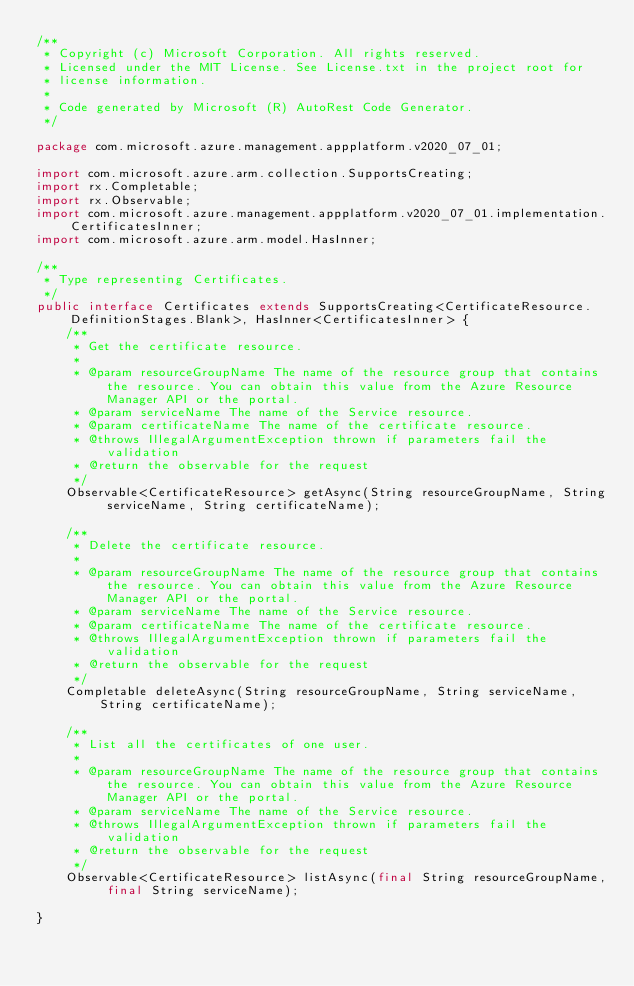<code> <loc_0><loc_0><loc_500><loc_500><_Java_>/**
 * Copyright (c) Microsoft Corporation. All rights reserved.
 * Licensed under the MIT License. See License.txt in the project root for
 * license information.
 *
 * Code generated by Microsoft (R) AutoRest Code Generator.
 */

package com.microsoft.azure.management.appplatform.v2020_07_01;

import com.microsoft.azure.arm.collection.SupportsCreating;
import rx.Completable;
import rx.Observable;
import com.microsoft.azure.management.appplatform.v2020_07_01.implementation.CertificatesInner;
import com.microsoft.azure.arm.model.HasInner;

/**
 * Type representing Certificates.
 */
public interface Certificates extends SupportsCreating<CertificateResource.DefinitionStages.Blank>, HasInner<CertificatesInner> {
    /**
     * Get the certificate resource.
     *
     * @param resourceGroupName The name of the resource group that contains the resource. You can obtain this value from the Azure Resource Manager API or the portal.
     * @param serviceName The name of the Service resource.
     * @param certificateName The name of the certificate resource.
     * @throws IllegalArgumentException thrown if parameters fail the validation
     * @return the observable for the request
     */
    Observable<CertificateResource> getAsync(String resourceGroupName, String serviceName, String certificateName);

    /**
     * Delete the certificate resource.
     *
     * @param resourceGroupName The name of the resource group that contains the resource. You can obtain this value from the Azure Resource Manager API or the portal.
     * @param serviceName The name of the Service resource.
     * @param certificateName The name of the certificate resource.
     * @throws IllegalArgumentException thrown if parameters fail the validation
     * @return the observable for the request
     */
    Completable deleteAsync(String resourceGroupName, String serviceName, String certificateName);

    /**
     * List all the certificates of one user.
     *
     * @param resourceGroupName The name of the resource group that contains the resource. You can obtain this value from the Azure Resource Manager API or the portal.
     * @param serviceName The name of the Service resource.
     * @throws IllegalArgumentException thrown if parameters fail the validation
     * @return the observable for the request
     */
    Observable<CertificateResource> listAsync(final String resourceGroupName, final String serviceName);

}
</code> 